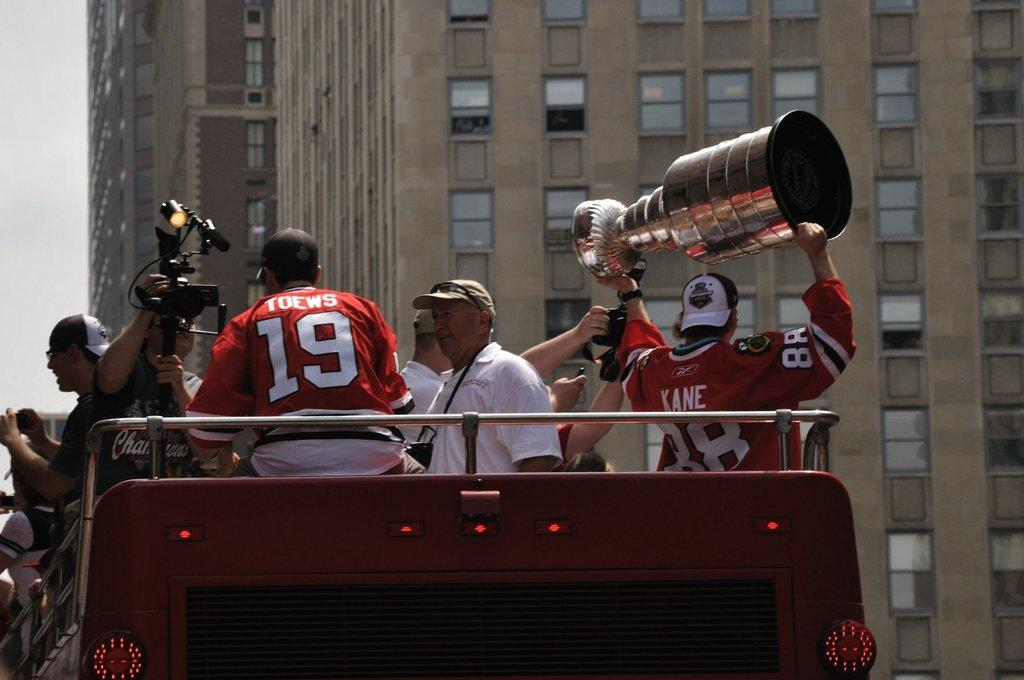Provide a one-sentence caption for the provided image. Man wearing a jersey saying Kane holding up a trophy. 